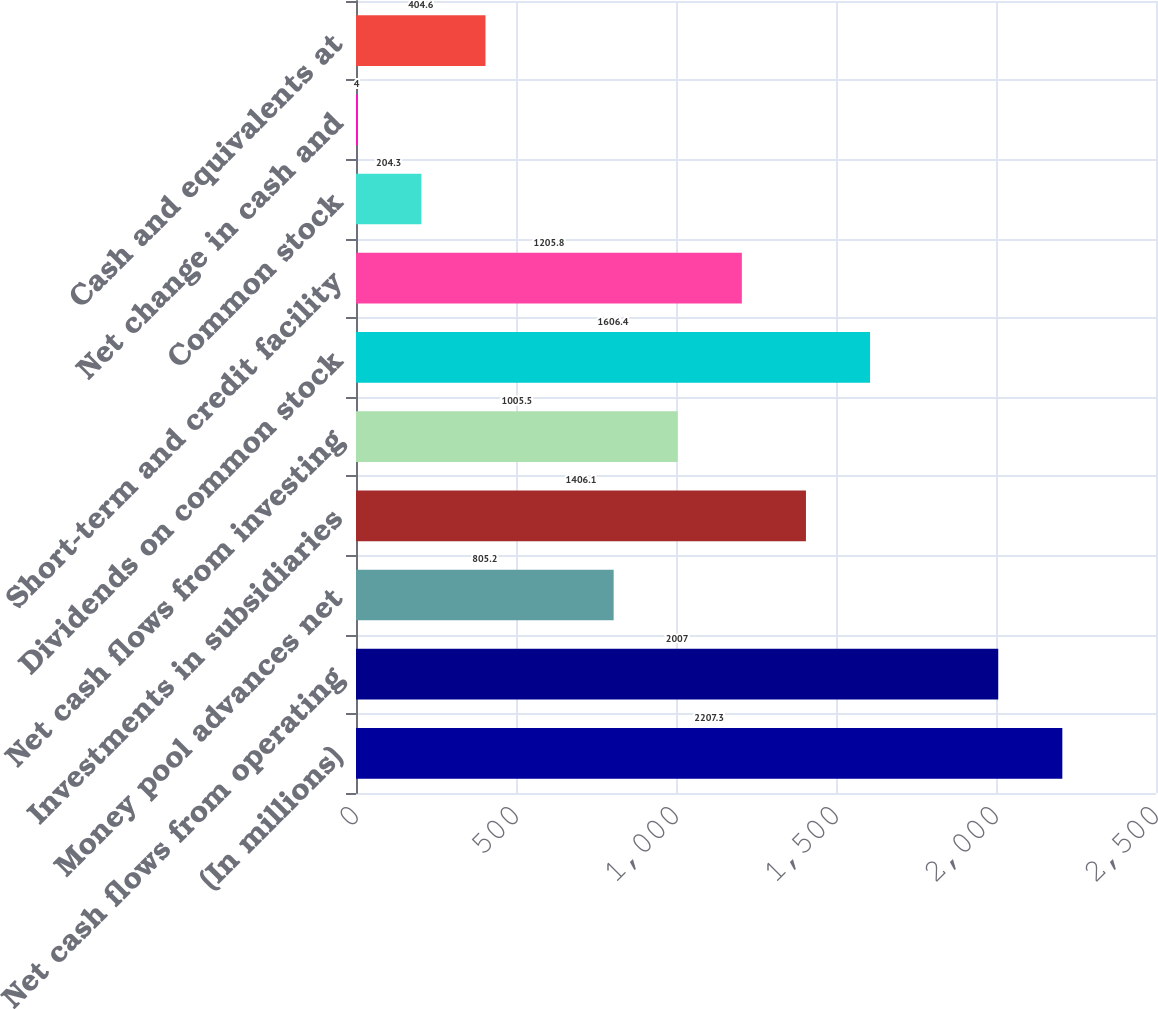<chart> <loc_0><loc_0><loc_500><loc_500><bar_chart><fcel>(In millions)<fcel>Net cash flows from operating<fcel>Money pool advances net<fcel>Investments in subsidiaries<fcel>Net cash flows from investing<fcel>Dividends on common stock<fcel>Short-term and credit facility<fcel>Common stock<fcel>Net change in cash and<fcel>Cash and equivalents at<nl><fcel>2207.3<fcel>2007<fcel>805.2<fcel>1406.1<fcel>1005.5<fcel>1606.4<fcel>1205.8<fcel>204.3<fcel>4<fcel>404.6<nl></chart> 